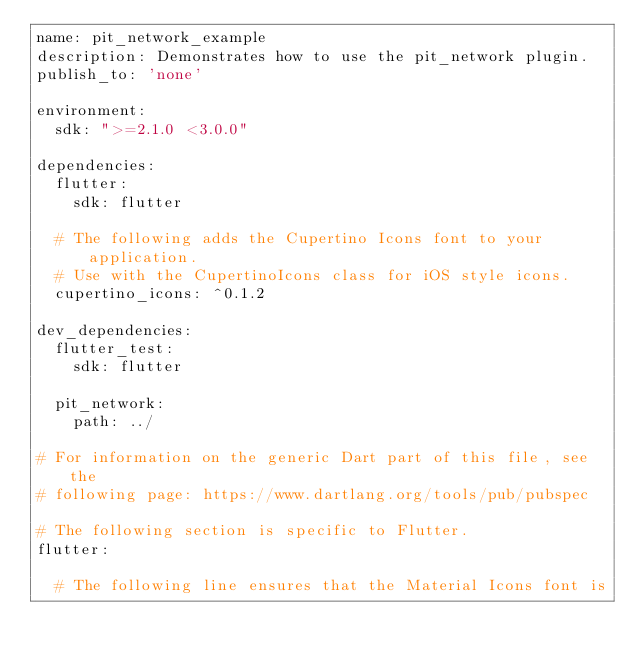<code> <loc_0><loc_0><loc_500><loc_500><_YAML_>name: pit_network_example
description: Demonstrates how to use the pit_network plugin.
publish_to: 'none'

environment:
  sdk: ">=2.1.0 <3.0.0"

dependencies:
  flutter:
    sdk: flutter

  # The following adds the Cupertino Icons font to your application.
  # Use with the CupertinoIcons class for iOS style icons.
  cupertino_icons: ^0.1.2

dev_dependencies:
  flutter_test:
    sdk: flutter

  pit_network:
    path: ../

# For information on the generic Dart part of this file, see the
# following page: https://www.dartlang.org/tools/pub/pubspec

# The following section is specific to Flutter.
flutter:

  # The following line ensures that the Material Icons font is</code> 